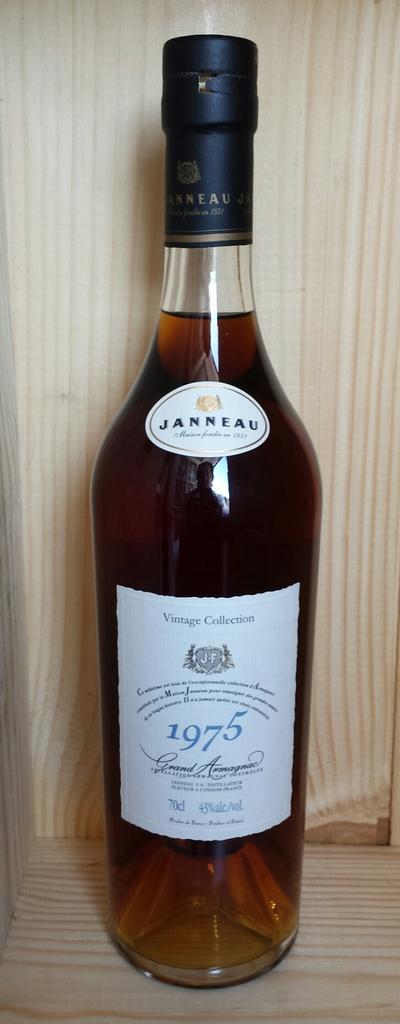How would you summarize this image in a sentence or two? In this image there is a bottle with black colour lid. On the bottle there is a label which we can read 1975 which is kept on the table. 